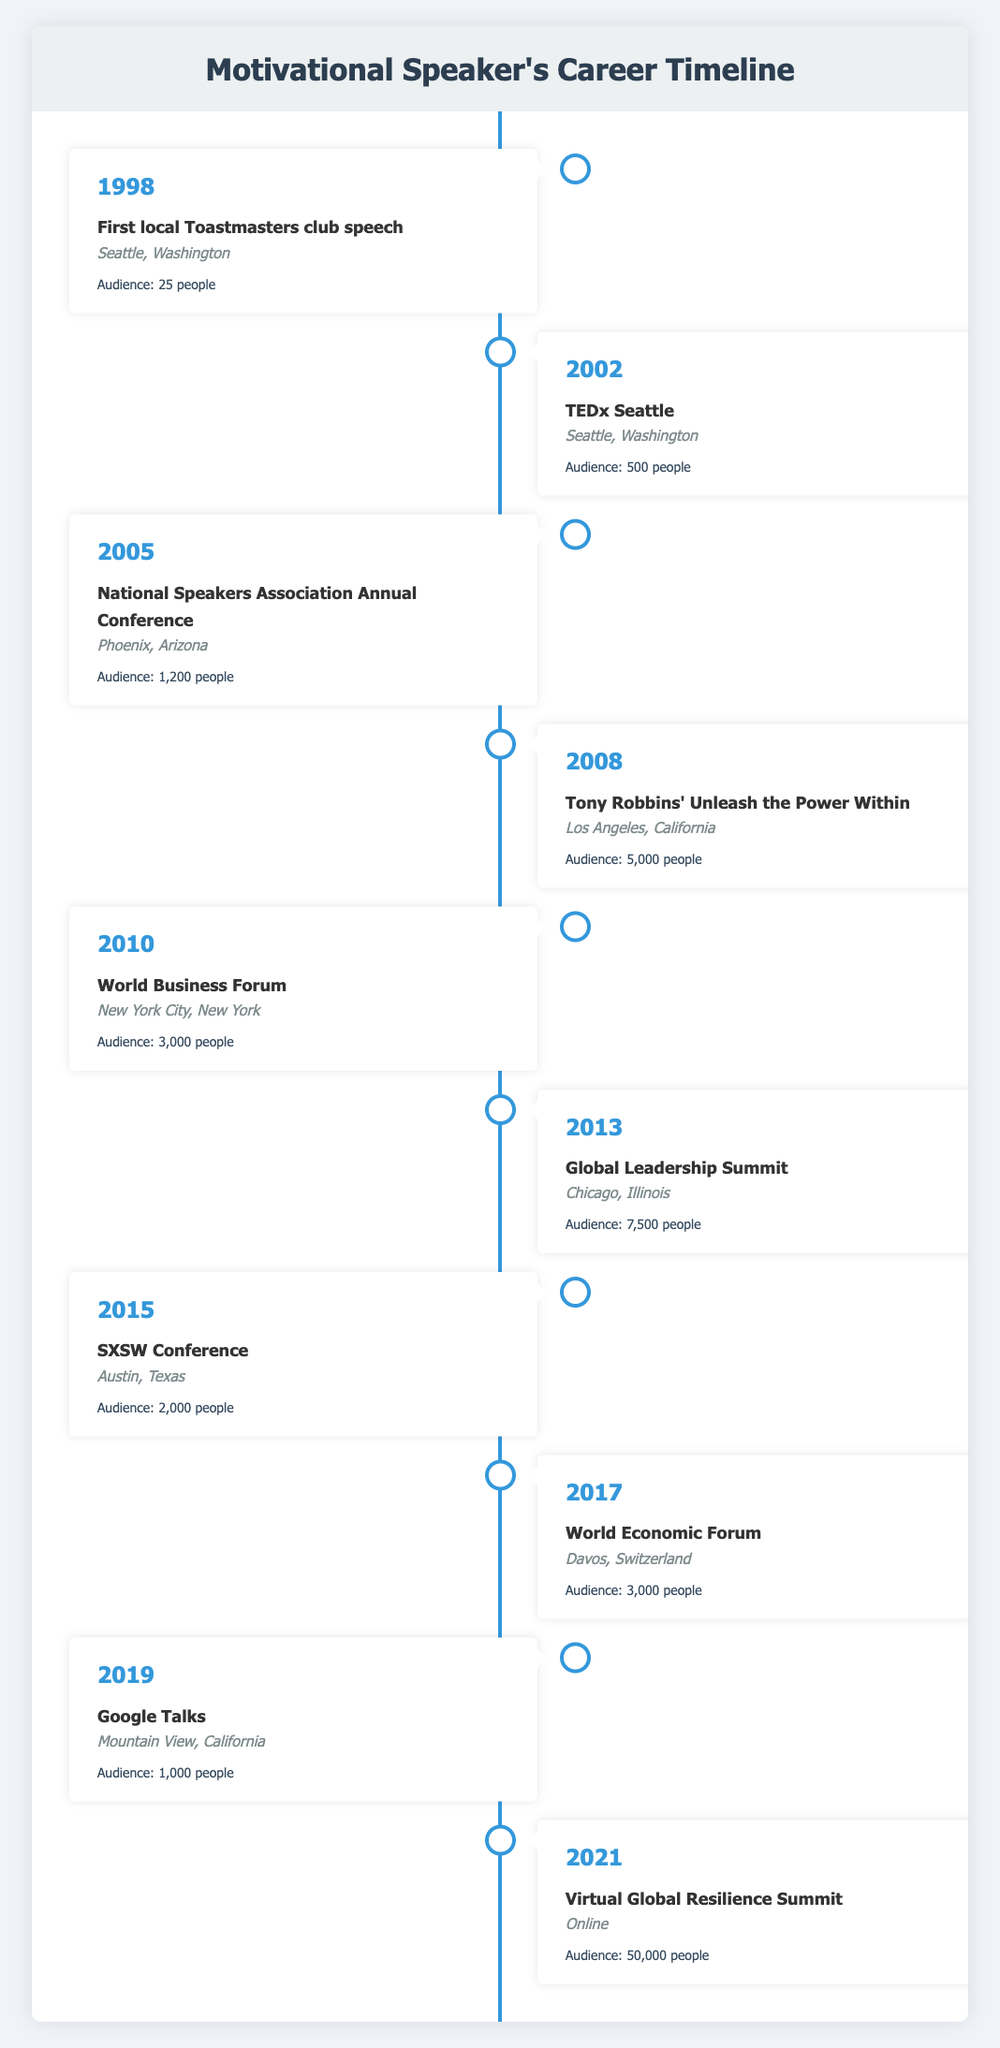What was the first major speaking event listed in the timeline? Looking at the timeline, the first event is from 1998, which is the "First local Toastmasters club speech" held in Seattle, Washington.
Answer: First local Toastmasters club speech How many people attended the Global Leadership Summit in 2013? Referring to the timeline for the year 2013, the event listed is the "Global Leadership Summit," which had an audience of 7,500 people.
Answer: 7500 people In which year did the largest audience attend an event? To find this, we look at the audience numbers for all events. The highest number is 50,000 for the "Virtual Global Resilience Summit" in 2021.
Answer: 2021 What is the average audience size across all events listed? First, sum the audience sizes: 25 + 500 + 1200 + 5000 + 3000 + 7500 + 2000 + 3000 + 1000 + 50000 = 68525. There are 10 events, so the average is 68525 / 10 = 6852.5.
Answer: 6852.5 Did the speaker present at an event with an audience size of 1,200 in 2005? Yes, in 2005 the event listed is the "National Speakers Association Annual Conference" and it had an audience of 1,200 people.
Answer: Yes What event had the lowest audience and what was that size? The event with the lowest audience listed is the "First local Toastmasters club speech" in 1998, which had an audience of 25 people.
Answer: First local Toastmasters club speech, 25 people Which two events had an audience of 3,000 people? The timeline shows two events with an audience of 3,000 people: "World Business Forum" in 2010 and "World Economic Forum" in 2017.
Answer: World Business Forum, World Economic Forum How many more people attended the Tony Robbins event compared to the TEDx Seattle event? The Tony Robbins event in 2008 had 5,000 attendees, while the TEDx Seattle event in 2002 had 500 attendees. The difference is 5000 - 500 = 4500.
Answer: 4500 Was there any event held entirely online listed in the timeline? Yes, the "Virtual Global Resilience Summit" held in 2021 was conducted online.
Answer: Yes 